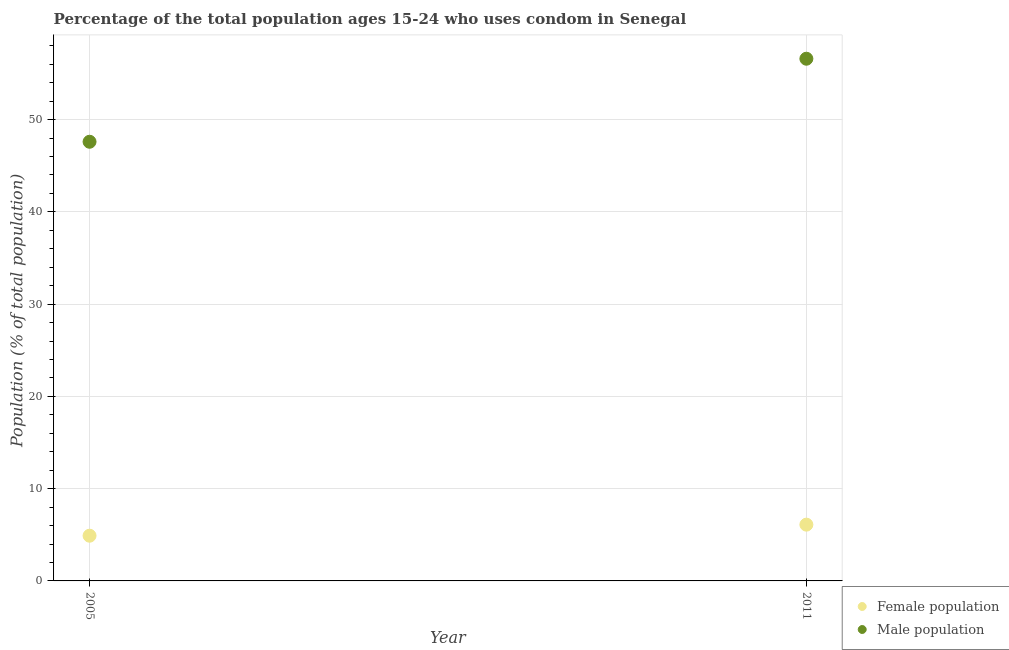Is the number of dotlines equal to the number of legend labels?
Your response must be concise. Yes. Across all years, what is the minimum male population?
Offer a terse response. 47.6. In which year was the female population maximum?
Your response must be concise. 2011. What is the difference between the male population in 2011 and the female population in 2005?
Provide a succinct answer. 51.7. What is the average female population per year?
Provide a short and direct response. 5.5. In the year 2011, what is the difference between the male population and female population?
Offer a terse response. 50.5. In how many years, is the male population greater than 10 %?
Ensure brevity in your answer.  2. What is the ratio of the female population in 2005 to that in 2011?
Make the answer very short. 0.8. In how many years, is the male population greater than the average male population taken over all years?
Your answer should be compact. 1. Does the male population monotonically increase over the years?
Your answer should be compact. Yes. Is the male population strictly greater than the female population over the years?
Ensure brevity in your answer.  Yes. Is the female population strictly less than the male population over the years?
Offer a terse response. Yes. How many years are there in the graph?
Your answer should be very brief. 2. What is the difference between two consecutive major ticks on the Y-axis?
Your answer should be compact. 10. Does the graph contain grids?
Offer a very short reply. Yes. Where does the legend appear in the graph?
Your answer should be compact. Bottom right. How many legend labels are there?
Offer a very short reply. 2. What is the title of the graph?
Your answer should be very brief. Percentage of the total population ages 15-24 who uses condom in Senegal. What is the label or title of the Y-axis?
Ensure brevity in your answer.  Population (% of total population) . What is the Population (% of total population)  of Male population in 2005?
Provide a short and direct response. 47.6. What is the Population (% of total population)  of Male population in 2011?
Your response must be concise. 56.6. Across all years, what is the maximum Population (% of total population)  in Female population?
Your answer should be very brief. 6.1. Across all years, what is the maximum Population (% of total population)  in Male population?
Offer a very short reply. 56.6. Across all years, what is the minimum Population (% of total population)  of Male population?
Offer a very short reply. 47.6. What is the total Population (% of total population)  of Male population in the graph?
Your response must be concise. 104.2. What is the difference between the Population (% of total population)  of Female population in 2005 and that in 2011?
Your answer should be compact. -1.2. What is the difference between the Population (% of total population)  in Male population in 2005 and that in 2011?
Your answer should be compact. -9. What is the difference between the Population (% of total population)  in Female population in 2005 and the Population (% of total population)  in Male population in 2011?
Offer a terse response. -51.7. What is the average Population (% of total population)  in Female population per year?
Your response must be concise. 5.5. What is the average Population (% of total population)  in Male population per year?
Offer a terse response. 52.1. In the year 2005, what is the difference between the Population (% of total population)  in Female population and Population (% of total population)  in Male population?
Make the answer very short. -42.7. In the year 2011, what is the difference between the Population (% of total population)  in Female population and Population (% of total population)  in Male population?
Make the answer very short. -50.5. What is the ratio of the Population (% of total population)  of Female population in 2005 to that in 2011?
Offer a very short reply. 0.8. What is the ratio of the Population (% of total population)  in Male population in 2005 to that in 2011?
Your answer should be compact. 0.84. What is the difference between the highest and the lowest Population (% of total population)  in Male population?
Provide a short and direct response. 9. 